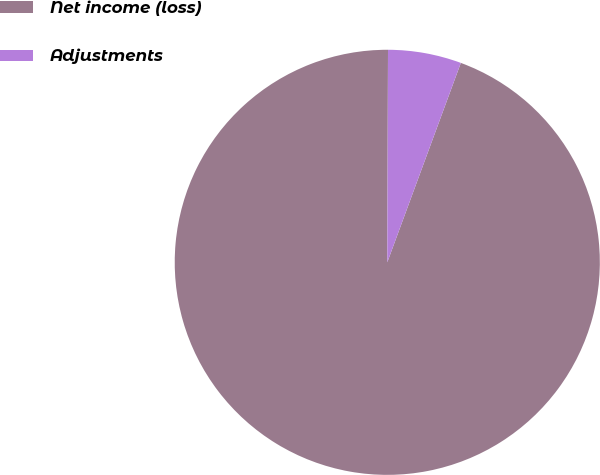Convert chart. <chart><loc_0><loc_0><loc_500><loc_500><pie_chart><fcel>Net income (loss)<fcel>Adjustments<nl><fcel>94.43%<fcel>5.57%<nl></chart> 